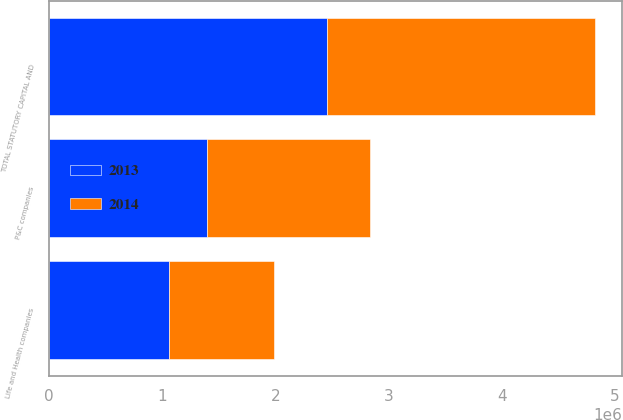Convert chart. <chart><loc_0><loc_0><loc_500><loc_500><stacked_bar_chart><ecel><fcel>P&C companies<fcel>Life and Health companies<fcel>TOTAL STATUTORY CAPITAL AND<nl><fcel>2013<fcel>1.3963e+06<fcel>1.06417e+06<fcel>2.46048e+06<nl><fcel>2014<fcel>1.44039e+06<fcel>923660<fcel>2.36405e+06<nl></chart> 